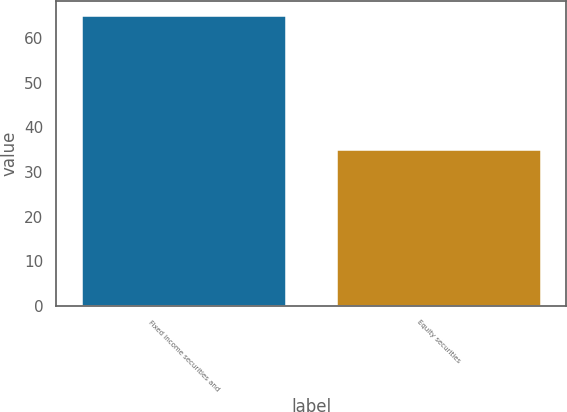Convert chart. <chart><loc_0><loc_0><loc_500><loc_500><bar_chart><fcel>Fixed income securities and<fcel>Equity securities<nl><fcel>65<fcel>35<nl></chart> 